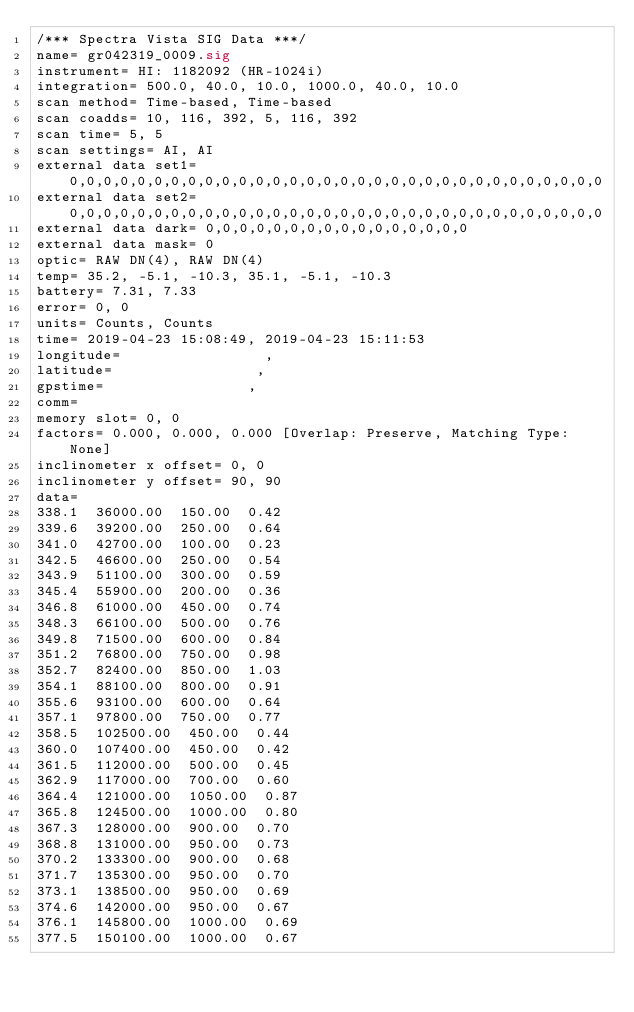<code> <loc_0><loc_0><loc_500><loc_500><_SML_>/*** Spectra Vista SIG Data ***/
name= gr042319_0009.sig
instrument= HI: 1182092 (HR-1024i)
integration= 500.0, 40.0, 10.0, 1000.0, 40.0, 10.0
scan method= Time-based, Time-based
scan coadds= 10, 116, 392, 5, 116, 392
scan time= 5, 5
scan settings= AI, AI
external data set1= 0,0,0,0,0,0,0,0,0,0,0,0,0,0,0,0,0,0,0,0,0,0,0,0,0,0,0,0,0,0,0,0
external data set2= 0,0,0,0,0,0,0,0,0,0,0,0,0,0,0,0,0,0,0,0,0,0,0,0,0,0,0,0,0,0,0,0
external data dark= 0,0,0,0,0,0,0,0,0,0,0,0,0,0,0,0
external data mask= 0
optic= RAW DN(4), RAW DN(4)
temp= 35.2, -5.1, -10.3, 35.1, -5.1, -10.3
battery= 7.31, 7.33
error= 0, 0
units= Counts, Counts
time= 2019-04-23 15:08:49, 2019-04-23 15:11:53
longitude=                 ,                 
latitude=                 ,                 
gpstime=                 ,                 
comm= 
memory slot= 0, 0
factors= 0.000, 0.000, 0.000 [Overlap: Preserve, Matching Type: None]
inclinometer x offset= 0, 0
inclinometer y offset= 90, 90
data= 
338.1  36000.00  150.00  0.42
339.6  39200.00  250.00  0.64
341.0  42700.00  100.00  0.23
342.5  46600.00  250.00  0.54
343.9  51100.00  300.00  0.59
345.4  55900.00  200.00  0.36
346.8  61000.00  450.00  0.74
348.3  66100.00  500.00  0.76
349.8  71500.00  600.00  0.84
351.2  76800.00  750.00  0.98
352.7  82400.00  850.00  1.03
354.1  88100.00  800.00  0.91
355.6  93100.00  600.00  0.64
357.1  97800.00  750.00  0.77
358.5  102500.00  450.00  0.44
360.0  107400.00  450.00  0.42
361.5  112000.00  500.00  0.45
362.9  117000.00  700.00  0.60
364.4  121000.00  1050.00  0.87
365.8  124500.00  1000.00  0.80
367.3  128000.00  900.00  0.70
368.8  131000.00  950.00  0.73
370.2  133300.00  900.00  0.68
371.7  135300.00  950.00  0.70
373.1  138500.00  950.00  0.69
374.6  142000.00  950.00  0.67
376.1  145800.00  1000.00  0.69
377.5  150100.00  1000.00  0.67</code> 